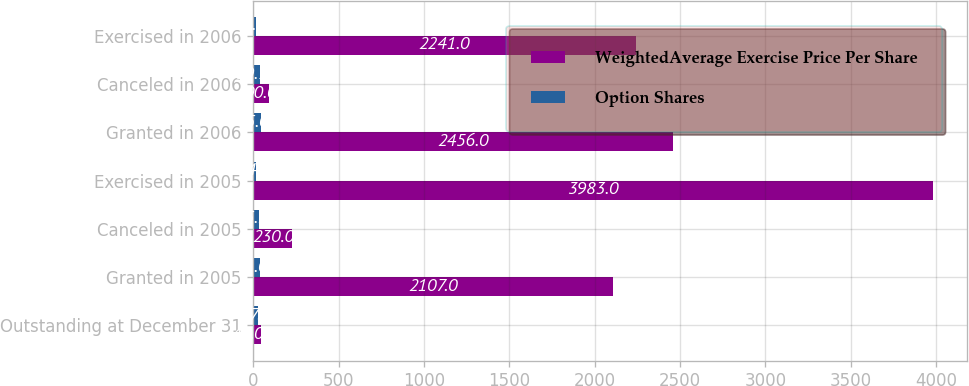<chart> <loc_0><loc_0><loc_500><loc_500><stacked_bar_chart><ecel><fcel>Outstanding at December 31<fcel>Granted in 2005<fcel>Canceled in 2005<fcel>Exercised in 2005<fcel>Granted in 2006<fcel>Canceled in 2006<fcel>Exercised in 2006<nl><fcel>WeightedAverage Exercise Price Per Share<fcel>43.045<fcel>2107<fcel>230<fcel>3983<fcel>2456<fcel>90<fcel>2241<nl><fcel>Option Shares<fcel>27.4<fcel>41.01<fcel>35.36<fcel>14.5<fcel>45.08<fcel>39.72<fcel>18.61<nl></chart> 